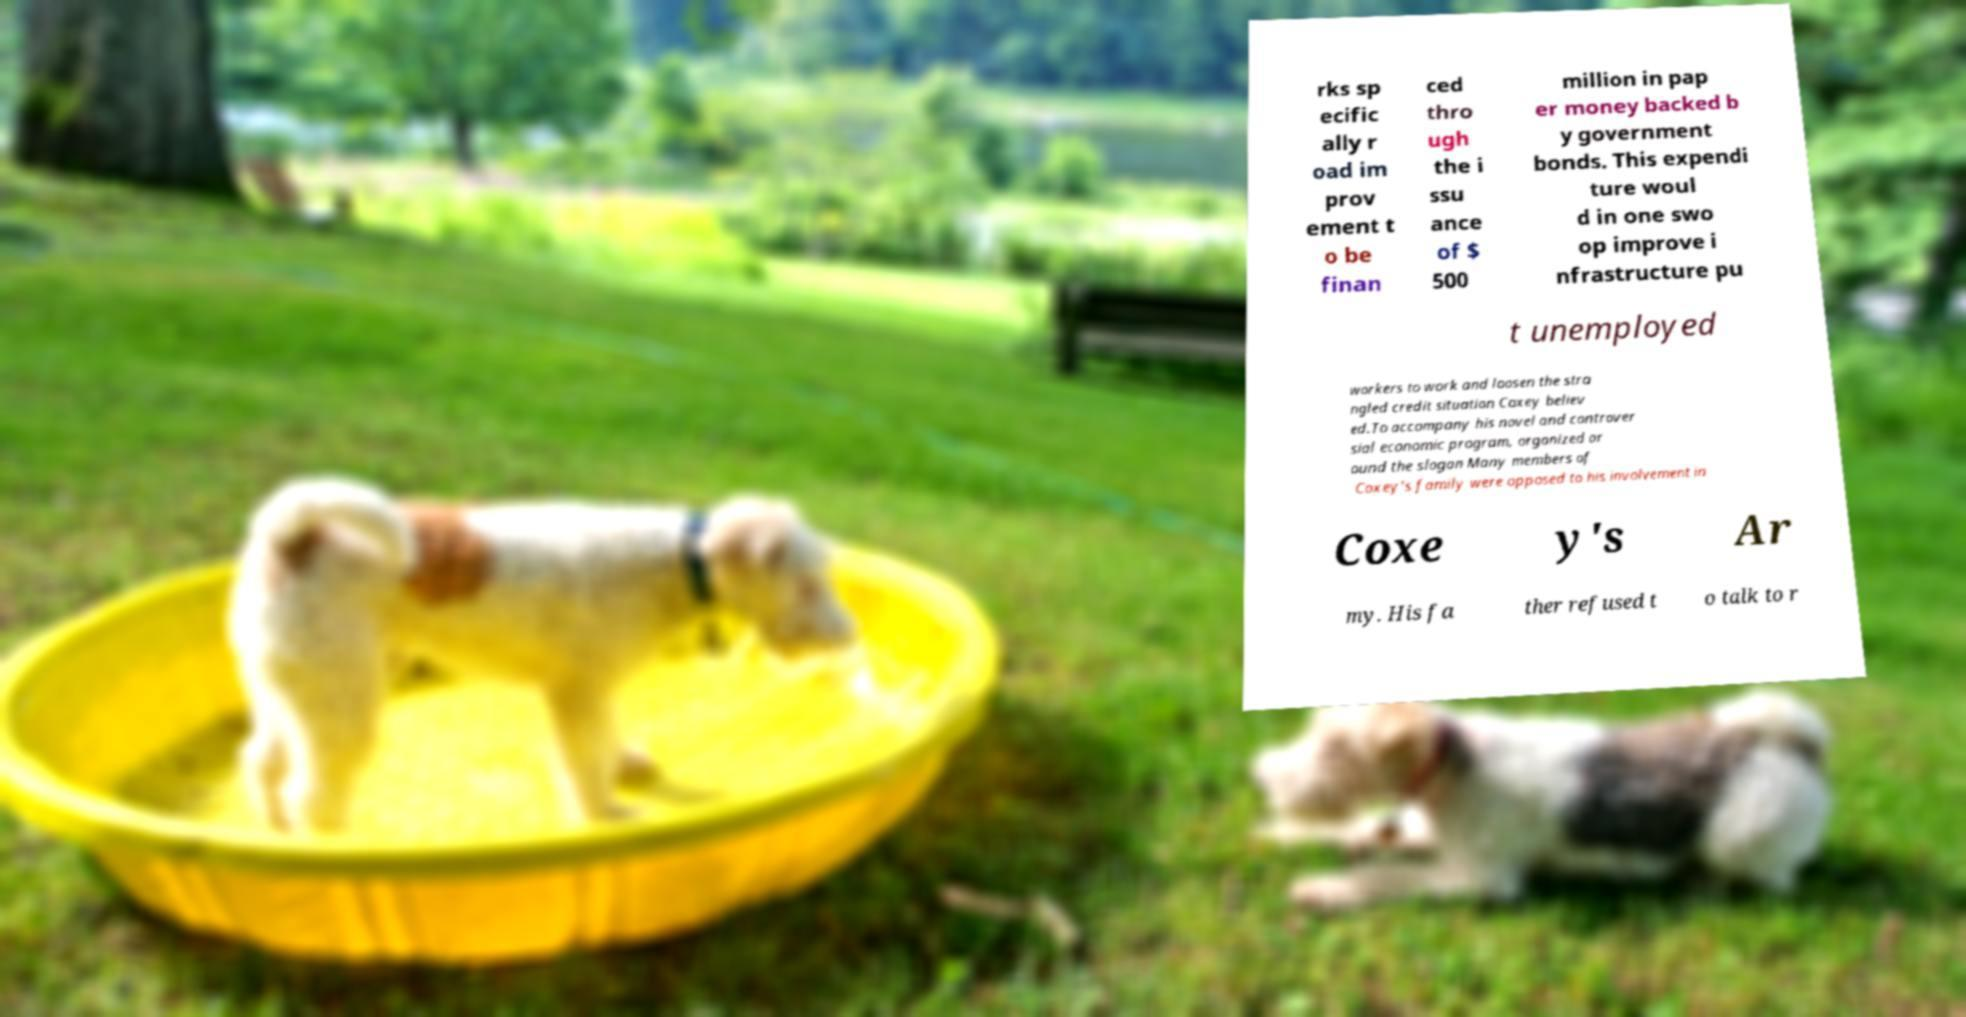For documentation purposes, I need the text within this image transcribed. Could you provide that? rks sp ecific ally r oad im prov ement t o be finan ced thro ugh the i ssu ance of $ 500 million in pap er money backed b y government bonds. This expendi ture woul d in one swo op improve i nfrastructure pu t unemployed workers to work and loosen the stra ngled credit situation Coxey believ ed.To accompany his novel and controver sial economic program, organized ar ound the slogan Many members of Coxey's family were opposed to his involvement in Coxe y's Ar my. His fa ther refused t o talk to r 